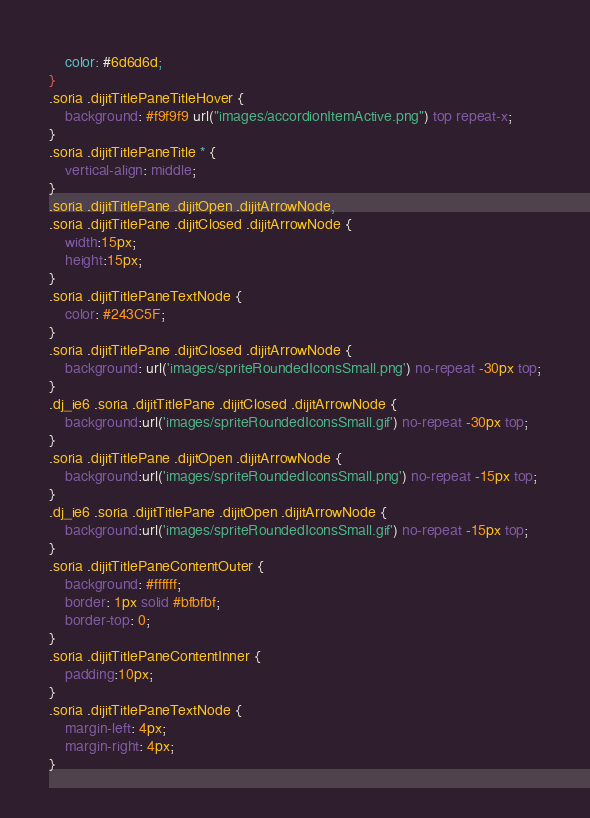<code> <loc_0><loc_0><loc_500><loc_500><_CSS_>	color: #6d6d6d;
}
.soria .dijitTitlePaneTitleHover {
	background: #f9f9f9 url("images/accordionItemActive.png") top repeat-x;
}
.soria .dijitTitlePaneTitle * {
	vertical-align: middle;
}
.soria .dijitTitlePane .dijitOpen .dijitArrowNode,
.soria .dijitTitlePane .dijitClosed .dijitArrowNode {
	width:15px;
	height:15px;
}
.soria .dijitTitlePaneTextNode {
	color: #243C5F;
}
.soria .dijitTitlePane .dijitClosed .dijitArrowNode {
	background: url('images/spriteRoundedIconsSmall.png') no-repeat -30px top;
}
.dj_ie6 .soria .dijitTitlePane .dijitClosed .dijitArrowNode {
	background:url('images/spriteRoundedIconsSmall.gif') no-repeat -30px top;
}
.soria .dijitTitlePane .dijitOpen .dijitArrowNode {
	background:url('images/spriteRoundedIconsSmall.png') no-repeat -15px top;
}
.dj_ie6 .soria .dijitTitlePane .dijitOpen .dijitArrowNode {
	background:url('images/spriteRoundedIconsSmall.gif') no-repeat -15px top;
}
.soria .dijitTitlePaneContentOuter {
	background: #ffffff;
	border: 1px solid #bfbfbf;
	border-top: 0;
}
.soria .dijitTitlePaneContentInner {
	padding:10px;
}
.soria .dijitTitlePaneTextNode {
	margin-left: 4px;
	margin-right: 4px;
}</code> 